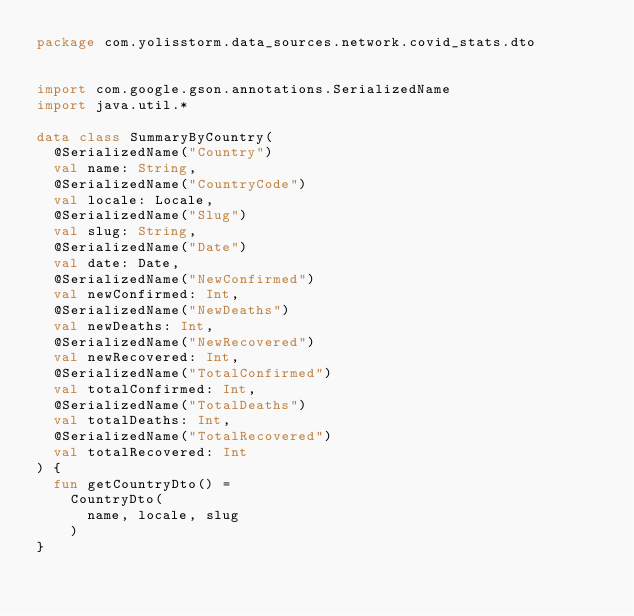<code> <loc_0><loc_0><loc_500><loc_500><_Kotlin_>package com.yolisstorm.data_sources.network.covid_stats.dto


import com.google.gson.annotations.SerializedName
import java.util.*

data class SummaryByCountry(
	@SerializedName("Country")
	val name: String,
	@SerializedName("CountryCode")
	val locale: Locale,
	@SerializedName("Slug")
	val slug: String,
	@SerializedName("Date")
	val date: Date,
	@SerializedName("NewConfirmed")
	val newConfirmed: Int,
	@SerializedName("NewDeaths")
	val newDeaths: Int,
	@SerializedName("NewRecovered")
	val newRecovered: Int,
	@SerializedName("TotalConfirmed")
	val totalConfirmed: Int,
	@SerializedName("TotalDeaths")
	val totalDeaths: Int,
	@SerializedName("TotalRecovered")
	val totalRecovered: Int
) {
	fun getCountryDto() =
		CountryDto(
			name, locale, slug
		)
}</code> 